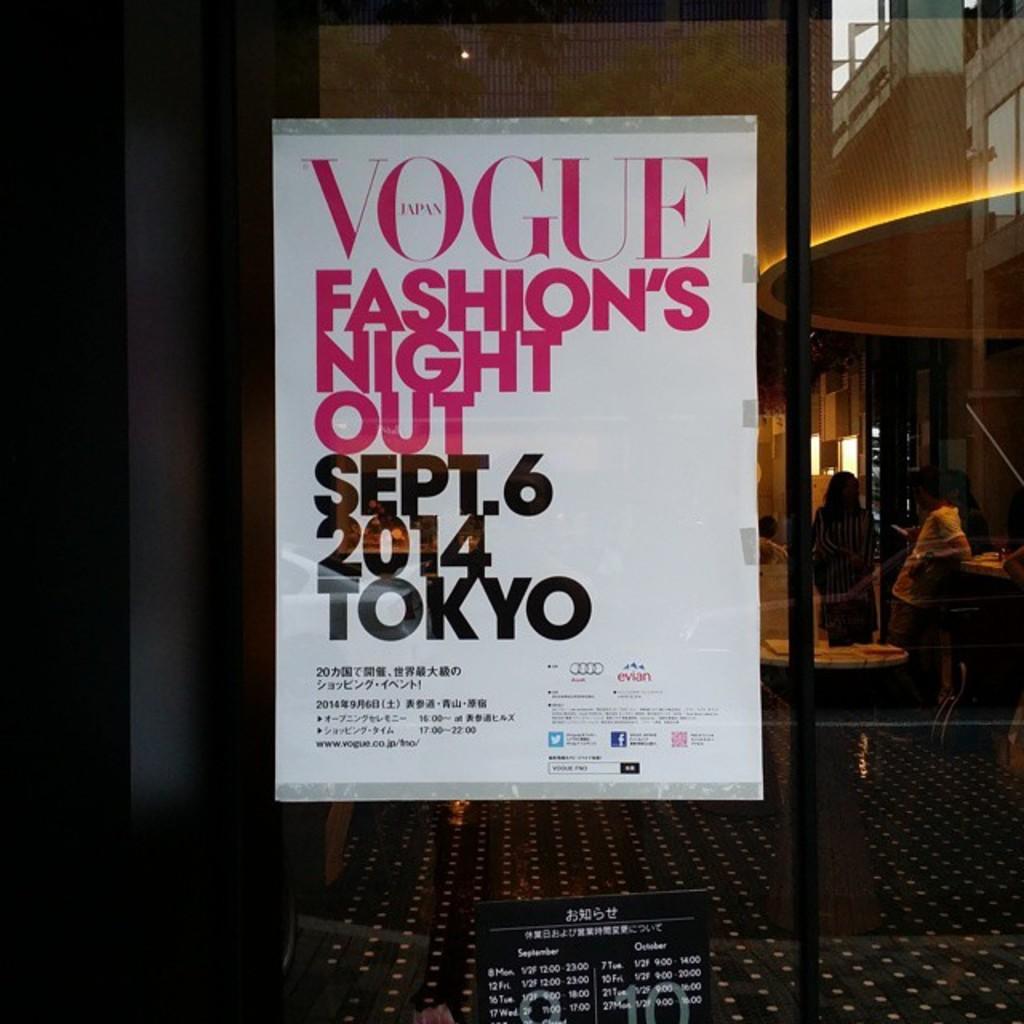Are they playing soccer?
Offer a terse response. Unanswerable. What date is the event?
Offer a terse response. Sept. 6 2014. 